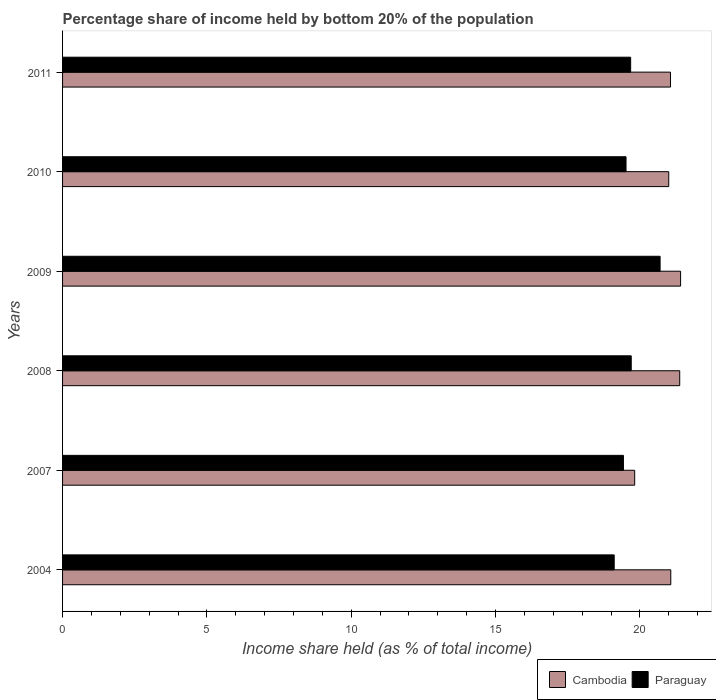How many different coloured bars are there?
Make the answer very short. 2. How many groups of bars are there?
Your answer should be compact. 6. Are the number of bars per tick equal to the number of legend labels?
Make the answer very short. Yes. How many bars are there on the 2nd tick from the top?
Your answer should be very brief. 2. What is the label of the 6th group of bars from the top?
Give a very brief answer. 2004. What is the share of income held by bottom 20% of the population in Cambodia in 2011?
Your answer should be very brief. 21.06. Across all years, what is the maximum share of income held by bottom 20% of the population in Cambodia?
Keep it short and to the point. 21.41. Across all years, what is the minimum share of income held by bottom 20% of the population in Paraguay?
Your answer should be compact. 19.11. In which year was the share of income held by bottom 20% of the population in Cambodia minimum?
Give a very brief answer. 2007. What is the total share of income held by bottom 20% of the population in Paraguay in the graph?
Make the answer very short. 118.14. What is the difference between the share of income held by bottom 20% of the population in Cambodia in 2004 and that in 2008?
Your response must be concise. -0.31. What is the difference between the share of income held by bottom 20% of the population in Paraguay in 2009 and the share of income held by bottom 20% of the population in Cambodia in 2007?
Offer a very short reply. 0.88. What is the average share of income held by bottom 20% of the population in Cambodia per year?
Provide a short and direct response. 20.96. In the year 2010, what is the difference between the share of income held by bottom 20% of the population in Paraguay and share of income held by bottom 20% of the population in Cambodia?
Your response must be concise. -1.48. What is the ratio of the share of income held by bottom 20% of the population in Cambodia in 2007 to that in 2011?
Provide a succinct answer. 0.94. What is the difference between the highest and the second highest share of income held by bottom 20% of the population in Paraguay?
Keep it short and to the point. 1. What is the difference between the highest and the lowest share of income held by bottom 20% of the population in Cambodia?
Offer a very short reply. 1.59. In how many years, is the share of income held by bottom 20% of the population in Paraguay greater than the average share of income held by bottom 20% of the population in Paraguay taken over all years?
Your answer should be very brief. 2. Is the sum of the share of income held by bottom 20% of the population in Cambodia in 2010 and 2011 greater than the maximum share of income held by bottom 20% of the population in Paraguay across all years?
Offer a terse response. Yes. What does the 1st bar from the top in 2007 represents?
Give a very brief answer. Paraguay. What does the 2nd bar from the bottom in 2008 represents?
Offer a terse response. Paraguay. Are all the bars in the graph horizontal?
Make the answer very short. Yes. How many years are there in the graph?
Your answer should be very brief. 6. What is the difference between two consecutive major ticks on the X-axis?
Your response must be concise. 5. Does the graph contain any zero values?
Ensure brevity in your answer.  No. Does the graph contain grids?
Give a very brief answer. No. What is the title of the graph?
Your answer should be compact. Percentage share of income held by bottom 20% of the population. Does "Belarus" appear as one of the legend labels in the graph?
Offer a very short reply. No. What is the label or title of the X-axis?
Make the answer very short. Income share held (as % of total income). What is the label or title of the Y-axis?
Your response must be concise. Years. What is the Income share held (as % of total income) of Cambodia in 2004?
Keep it short and to the point. 21.07. What is the Income share held (as % of total income) in Paraguay in 2004?
Your response must be concise. 19.11. What is the Income share held (as % of total income) of Cambodia in 2007?
Keep it short and to the point. 19.82. What is the Income share held (as % of total income) in Paraguay in 2007?
Make the answer very short. 19.43. What is the Income share held (as % of total income) in Cambodia in 2008?
Offer a terse response. 21.38. What is the Income share held (as % of total income) in Cambodia in 2009?
Make the answer very short. 21.41. What is the Income share held (as % of total income) in Paraguay in 2009?
Provide a succinct answer. 20.7. What is the Income share held (as % of total income) in Paraguay in 2010?
Your response must be concise. 19.52. What is the Income share held (as % of total income) of Cambodia in 2011?
Your response must be concise. 21.06. What is the Income share held (as % of total income) in Paraguay in 2011?
Provide a succinct answer. 19.68. Across all years, what is the maximum Income share held (as % of total income) of Cambodia?
Provide a succinct answer. 21.41. Across all years, what is the maximum Income share held (as % of total income) of Paraguay?
Give a very brief answer. 20.7. Across all years, what is the minimum Income share held (as % of total income) in Cambodia?
Offer a very short reply. 19.82. Across all years, what is the minimum Income share held (as % of total income) in Paraguay?
Your answer should be very brief. 19.11. What is the total Income share held (as % of total income) of Cambodia in the graph?
Provide a short and direct response. 125.74. What is the total Income share held (as % of total income) of Paraguay in the graph?
Keep it short and to the point. 118.14. What is the difference between the Income share held (as % of total income) of Paraguay in 2004 and that in 2007?
Provide a succinct answer. -0.32. What is the difference between the Income share held (as % of total income) in Cambodia in 2004 and that in 2008?
Offer a terse response. -0.31. What is the difference between the Income share held (as % of total income) of Paraguay in 2004 and that in 2008?
Your answer should be very brief. -0.59. What is the difference between the Income share held (as % of total income) of Cambodia in 2004 and that in 2009?
Ensure brevity in your answer.  -0.34. What is the difference between the Income share held (as % of total income) in Paraguay in 2004 and that in 2009?
Provide a succinct answer. -1.59. What is the difference between the Income share held (as % of total income) in Cambodia in 2004 and that in 2010?
Offer a terse response. 0.07. What is the difference between the Income share held (as % of total income) of Paraguay in 2004 and that in 2010?
Provide a short and direct response. -0.41. What is the difference between the Income share held (as % of total income) in Paraguay in 2004 and that in 2011?
Your answer should be very brief. -0.57. What is the difference between the Income share held (as % of total income) in Cambodia in 2007 and that in 2008?
Your answer should be compact. -1.56. What is the difference between the Income share held (as % of total income) of Paraguay in 2007 and that in 2008?
Make the answer very short. -0.27. What is the difference between the Income share held (as % of total income) in Cambodia in 2007 and that in 2009?
Make the answer very short. -1.59. What is the difference between the Income share held (as % of total income) of Paraguay in 2007 and that in 2009?
Offer a terse response. -1.27. What is the difference between the Income share held (as % of total income) in Cambodia in 2007 and that in 2010?
Keep it short and to the point. -1.18. What is the difference between the Income share held (as % of total income) in Paraguay in 2007 and that in 2010?
Provide a succinct answer. -0.09. What is the difference between the Income share held (as % of total income) of Cambodia in 2007 and that in 2011?
Your response must be concise. -1.24. What is the difference between the Income share held (as % of total income) of Cambodia in 2008 and that in 2009?
Offer a terse response. -0.03. What is the difference between the Income share held (as % of total income) of Paraguay in 2008 and that in 2009?
Ensure brevity in your answer.  -1. What is the difference between the Income share held (as % of total income) of Cambodia in 2008 and that in 2010?
Offer a terse response. 0.38. What is the difference between the Income share held (as % of total income) in Paraguay in 2008 and that in 2010?
Offer a terse response. 0.18. What is the difference between the Income share held (as % of total income) of Cambodia in 2008 and that in 2011?
Offer a very short reply. 0.32. What is the difference between the Income share held (as % of total income) in Cambodia in 2009 and that in 2010?
Offer a terse response. 0.41. What is the difference between the Income share held (as % of total income) of Paraguay in 2009 and that in 2010?
Your answer should be compact. 1.18. What is the difference between the Income share held (as % of total income) in Paraguay in 2009 and that in 2011?
Your response must be concise. 1.02. What is the difference between the Income share held (as % of total income) of Cambodia in 2010 and that in 2011?
Offer a terse response. -0.06. What is the difference between the Income share held (as % of total income) of Paraguay in 2010 and that in 2011?
Provide a succinct answer. -0.16. What is the difference between the Income share held (as % of total income) in Cambodia in 2004 and the Income share held (as % of total income) in Paraguay in 2007?
Offer a very short reply. 1.64. What is the difference between the Income share held (as % of total income) of Cambodia in 2004 and the Income share held (as % of total income) of Paraguay in 2008?
Your answer should be very brief. 1.37. What is the difference between the Income share held (as % of total income) of Cambodia in 2004 and the Income share held (as % of total income) of Paraguay in 2009?
Give a very brief answer. 0.37. What is the difference between the Income share held (as % of total income) of Cambodia in 2004 and the Income share held (as % of total income) of Paraguay in 2010?
Offer a terse response. 1.55. What is the difference between the Income share held (as % of total income) in Cambodia in 2004 and the Income share held (as % of total income) in Paraguay in 2011?
Ensure brevity in your answer.  1.39. What is the difference between the Income share held (as % of total income) of Cambodia in 2007 and the Income share held (as % of total income) of Paraguay in 2008?
Offer a very short reply. 0.12. What is the difference between the Income share held (as % of total income) in Cambodia in 2007 and the Income share held (as % of total income) in Paraguay in 2009?
Offer a terse response. -0.88. What is the difference between the Income share held (as % of total income) of Cambodia in 2007 and the Income share held (as % of total income) of Paraguay in 2010?
Keep it short and to the point. 0.3. What is the difference between the Income share held (as % of total income) in Cambodia in 2007 and the Income share held (as % of total income) in Paraguay in 2011?
Make the answer very short. 0.14. What is the difference between the Income share held (as % of total income) in Cambodia in 2008 and the Income share held (as % of total income) in Paraguay in 2009?
Your response must be concise. 0.68. What is the difference between the Income share held (as % of total income) in Cambodia in 2008 and the Income share held (as % of total income) in Paraguay in 2010?
Provide a short and direct response. 1.86. What is the difference between the Income share held (as % of total income) of Cambodia in 2008 and the Income share held (as % of total income) of Paraguay in 2011?
Provide a short and direct response. 1.7. What is the difference between the Income share held (as % of total income) of Cambodia in 2009 and the Income share held (as % of total income) of Paraguay in 2010?
Give a very brief answer. 1.89. What is the difference between the Income share held (as % of total income) in Cambodia in 2009 and the Income share held (as % of total income) in Paraguay in 2011?
Provide a succinct answer. 1.73. What is the difference between the Income share held (as % of total income) in Cambodia in 2010 and the Income share held (as % of total income) in Paraguay in 2011?
Your answer should be compact. 1.32. What is the average Income share held (as % of total income) of Cambodia per year?
Your answer should be compact. 20.96. What is the average Income share held (as % of total income) of Paraguay per year?
Ensure brevity in your answer.  19.69. In the year 2004, what is the difference between the Income share held (as % of total income) of Cambodia and Income share held (as % of total income) of Paraguay?
Make the answer very short. 1.96. In the year 2007, what is the difference between the Income share held (as % of total income) in Cambodia and Income share held (as % of total income) in Paraguay?
Your answer should be compact. 0.39. In the year 2008, what is the difference between the Income share held (as % of total income) in Cambodia and Income share held (as % of total income) in Paraguay?
Your answer should be very brief. 1.68. In the year 2009, what is the difference between the Income share held (as % of total income) in Cambodia and Income share held (as % of total income) in Paraguay?
Make the answer very short. 0.71. In the year 2010, what is the difference between the Income share held (as % of total income) in Cambodia and Income share held (as % of total income) in Paraguay?
Make the answer very short. 1.48. In the year 2011, what is the difference between the Income share held (as % of total income) of Cambodia and Income share held (as % of total income) of Paraguay?
Provide a short and direct response. 1.38. What is the ratio of the Income share held (as % of total income) of Cambodia in 2004 to that in 2007?
Keep it short and to the point. 1.06. What is the ratio of the Income share held (as % of total income) of Paraguay in 2004 to that in 2007?
Provide a succinct answer. 0.98. What is the ratio of the Income share held (as % of total income) in Cambodia in 2004 to that in 2008?
Make the answer very short. 0.99. What is the ratio of the Income share held (as % of total income) of Paraguay in 2004 to that in 2008?
Offer a terse response. 0.97. What is the ratio of the Income share held (as % of total income) of Cambodia in 2004 to that in 2009?
Keep it short and to the point. 0.98. What is the ratio of the Income share held (as % of total income) of Paraguay in 2004 to that in 2009?
Make the answer very short. 0.92. What is the ratio of the Income share held (as % of total income) in Cambodia in 2004 to that in 2010?
Your response must be concise. 1. What is the ratio of the Income share held (as % of total income) in Paraguay in 2004 to that in 2010?
Offer a very short reply. 0.98. What is the ratio of the Income share held (as % of total income) in Cambodia in 2004 to that in 2011?
Provide a succinct answer. 1. What is the ratio of the Income share held (as % of total income) in Paraguay in 2004 to that in 2011?
Provide a short and direct response. 0.97. What is the ratio of the Income share held (as % of total income) in Cambodia in 2007 to that in 2008?
Provide a succinct answer. 0.93. What is the ratio of the Income share held (as % of total income) in Paraguay in 2007 to that in 2008?
Your answer should be compact. 0.99. What is the ratio of the Income share held (as % of total income) in Cambodia in 2007 to that in 2009?
Provide a short and direct response. 0.93. What is the ratio of the Income share held (as % of total income) in Paraguay in 2007 to that in 2009?
Provide a short and direct response. 0.94. What is the ratio of the Income share held (as % of total income) of Cambodia in 2007 to that in 2010?
Keep it short and to the point. 0.94. What is the ratio of the Income share held (as % of total income) of Paraguay in 2007 to that in 2010?
Ensure brevity in your answer.  1. What is the ratio of the Income share held (as % of total income) in Cambodia in 2007 to that in 2011?
Provide a short and direct response. 0.94. What is the ratio of the Income share held (as % of total income) of Paraguay in 2007 to that in 2011?
Provide a short and direct response. 0.99. What is the ratio of the Income share held (as % of total income) in Paraguay in 2008 to that in 2009?
Make the answer very short. 0.95. What is the ratio of the Income share held (as % of total income) of Cambodia in 2008 to that in 2010?
Your response must be concise. 1.02. What is the ratio of the Income share held (as % of total income) in Paraguay in 2008 to that in 2010?
Your answer should be very brief. 1.01. What is the ratio of the Income share held (as % of total income) of Cambodia in 2008 to that in 2011?
Give a very brief answer. 1.02. What is the ratio of the Income share held (as % of total income) in Paraguay in 2008 to that in 2011?
Offer a terse response. 1. What is the ratio of the Income share held (as % of total income) of Cambodia in 2009 to that in 2010?
Offer a terse response. 1.02. What is the ratio of the Income share held (as % of total income) in Paraguay in 2009 to that in 2010?
Your answer should be very brief. 1.06. What is the ratio of the Income share held (as % of total income) in Cambodia in 2009 to that in 2011?
Your answer should be compact. 1.02. What is the ratio of the Income share held (as % of total income) of Paraguay in 2009 to that in 2011?
Make the answer very short. 1.05. What is the difference between the highest and the lowest Income share held (as % of total income) of Cambodia?
Give a very brief answer. 1.59. What is the difference between the highest and the lowest Income share held (as % of total income) in Paraguay?
Ensure brevity in your answer.  1.59. 